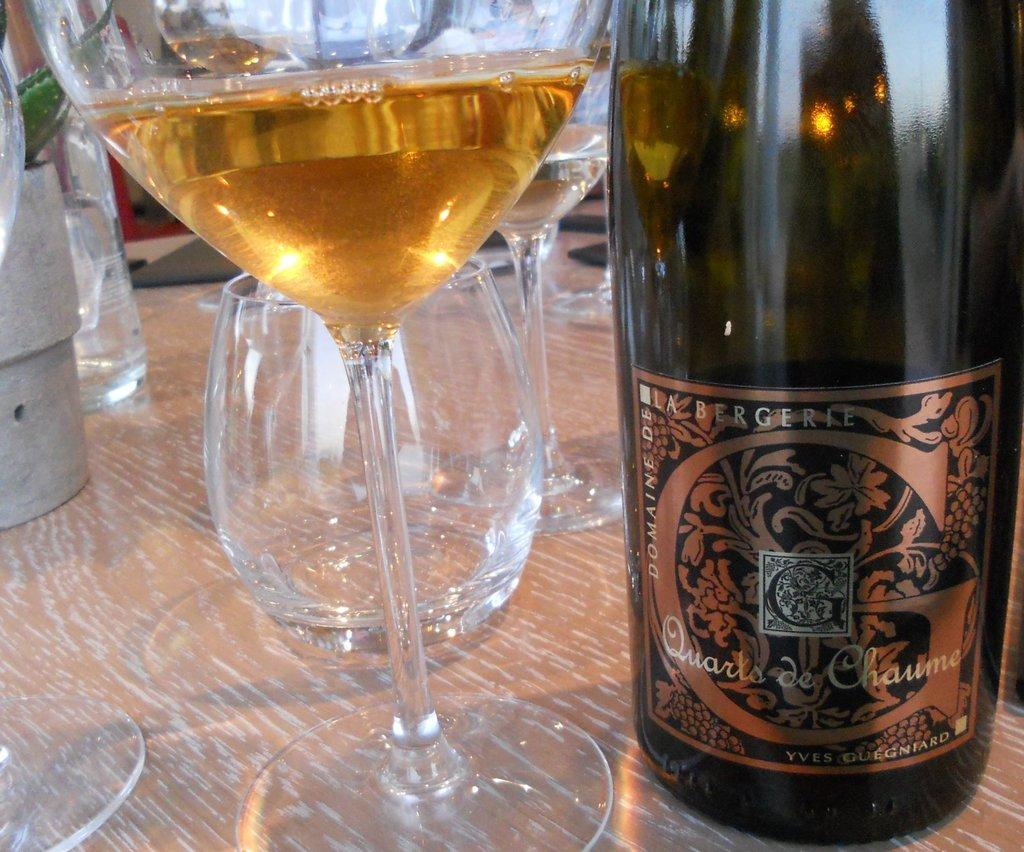Provide a one-sentence caption for the provided image. a DOMAINE DE LA BERGERIE Quarts de Chaume liquor bottle and a glass of it next to. 